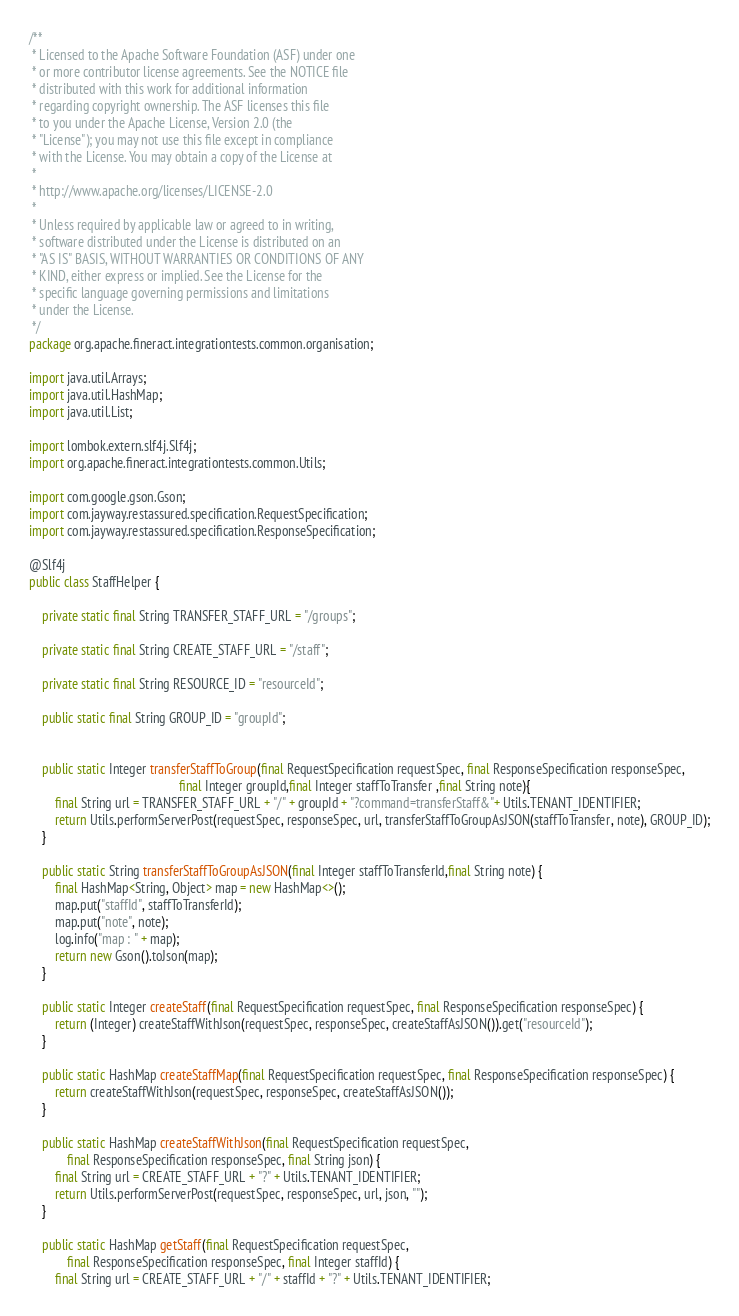<code> <loc_0><loc_0><loc_500><loc_500><_Java_>/**
 * Licensed to the Apache Software Foundation (ASF) under one
 * or more contributor license agreements. See the NOTICE file
 * distributed with this work for additional information
 * regarding copyright ownership. The ASF licenses this file
 * to you under the Apache License, Version 2.0 (the
 * "License"); you may not use this file except in compliance
 * with the License. You may obtain a copy of the License at
 *
 * http://www.apache.org/licenses/LICENSE-2.0
 *
 * Unless required by applicable law or agreed to in writing,
 * software distributed under the License is distributed on an
 * "AS IS" BASIS, WITHOUT WARRANTIES OR CONDITIONS OF ANY
 * KIND, either express or implied. See the License for the
 * specific language governing permissions and limitations
 * under the License.
 */
package org.apache.fineract.integrationtests.common.organisation;

import java.util.Arrays;
import java.util.HashMap;
import java.util.List;

import lombok.extern.slf4j.Slf4j;
import org.apache.fineract.integrationtests.common.Utils;

import com.google.gson.Gson;
import com.jayway.restassured.specification.RequestSpecification;
import com.jayway.restassured.specification.ResponseSpecification;

@Slf4j
public class StaffHelper {

    private static final String TRANSFER_STAFF_URL = "/groups";

    private static final String CREATE_STAFF_URL = "/staff";

    private static final String RESOURCE_ID = "resourceId";

    public static final String GROUP_ID = "groupId";


    public static Integer transferStaffToGroup(final RequestSpecification requestSpec, final ResponseSpecification responseSpec,
                                               final Integer groupId,final Integer staffToTransfer ,final String note){
        final String url = TRANSFER_STAFF_URL + "/" + groupId + "?command=transferStaff&"+ Utils.TENANT_IDENTIFIER;
        return Utils.performServerPost(requestSpec, responseSpec, url, transferStaffToGroupAsJSON(staffToTransfer, note), GROUP_ID);
    }

    public static String transferStaffToGroupAsJSON(final Integer staffToTransferId,final String note) {
        final HashMap<String, Object> map = new HashMap<>();
        map.put("staffId", staffToTransferId);
        map.put("note", note);
        log.info("map : " + map);
        return new Gson().toJson(map);
    }

    public static Integer createStaff(final RequestSpecification requestSpec, final ResponseSpecification responseSpec) {
        return (Integer) createStaffWithJson(requestSpec, responseSpec, createStaffAsJSON()).get("resourceId");
    }

    public static HashMap createStaffMap(final RequestSpecification requestSpec, final ResponseSpecification responseSpec) {
        return createStaffWithJson(requestSpec, responseSpec, createStaffAsJSON());
    }

    public static HashMap createStaffWithJson(final RequestSpecification requestSpec,
            final ResponseSpecification responseSpec, final String json) {
        final String url = CREATE_STAFF_URL + "?" + Utils.TENANT_IDENTIFIER;
        return Utils.performServerPost(requestSpec, responseSpec, url, json, "");
    }

    public static HashMap getStaff(final RequestSpecification requestSpec,
            final ResponseSpecification responseSpec, final Integer staffId) {
        final String url = CREATE_STAFF_URL + "/" + staffId + "?" + Utils.TENANT_IDENTIFIER;</code> 